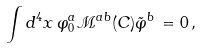Convert formula to latex. <formula><loc_0><loc_0><loc_500><loc_500>\int d ^ { 4 } x \, \varphi _ { 0 } ^ { a } \mathcal { M } ^ { a b } ( C ) \tilde { \varphi } ^ { b } \, = 0 \, ,</formula> 